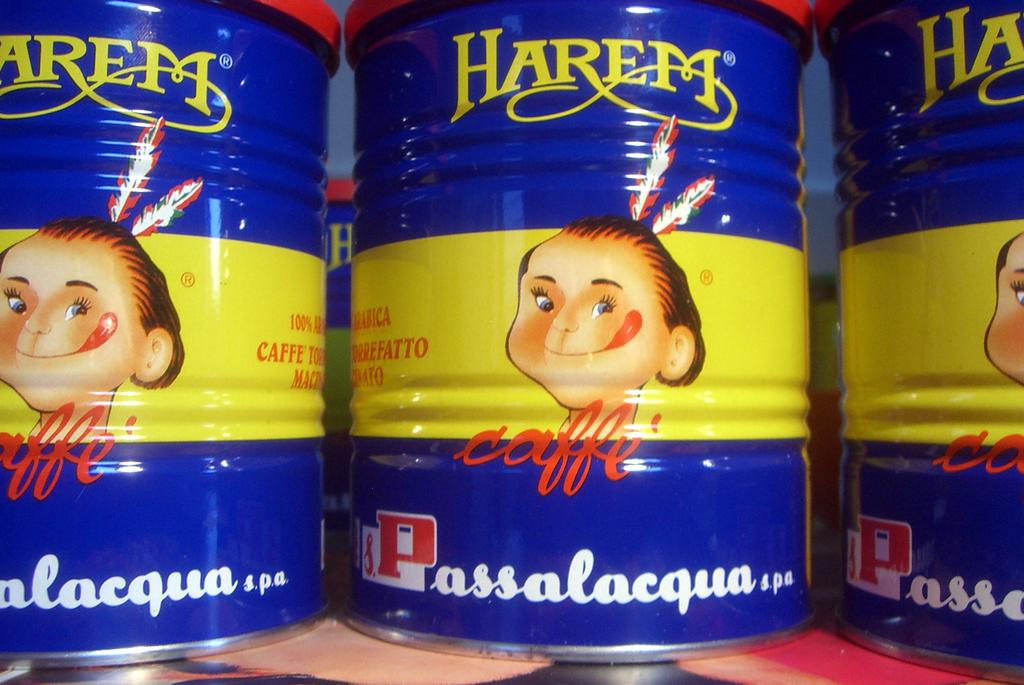<image>
Render a clear and concise summary of the photo. Three cans of Harem Caffe sit next to one another. 